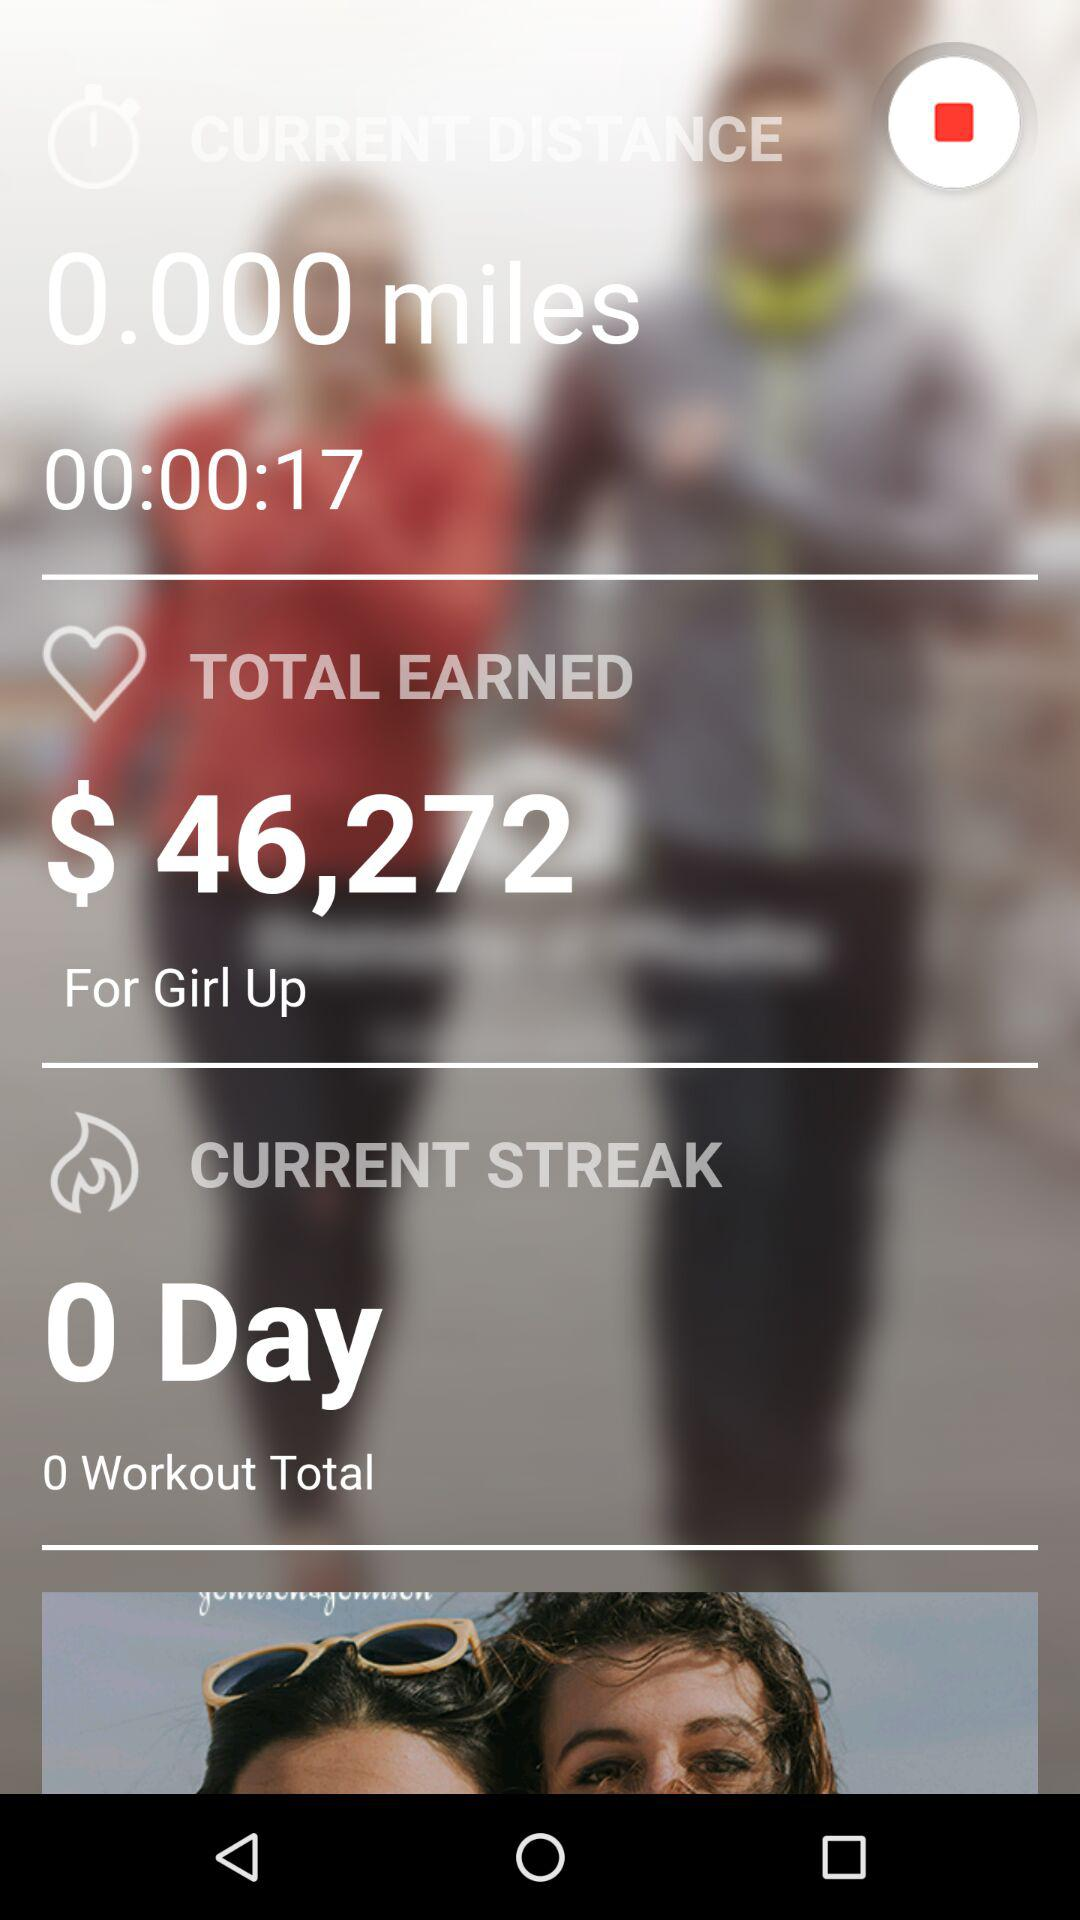How much is the total amount earned? The total earned amount is $46,272. 